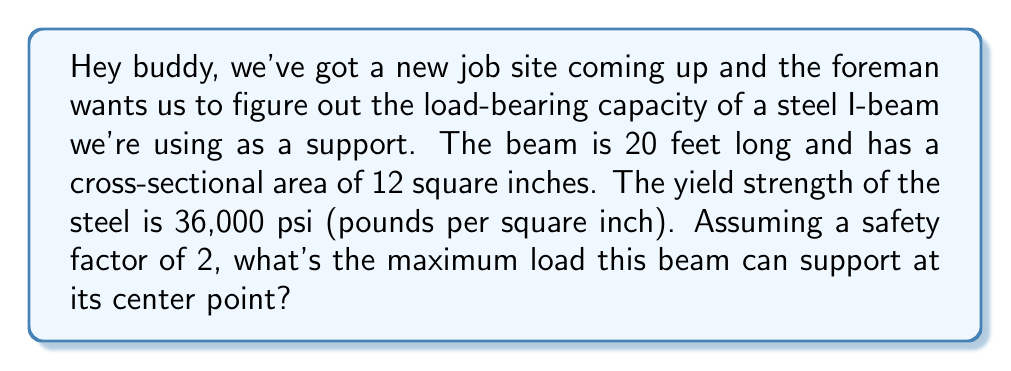Give your solution to this math problem. Alright, let's break this down step-by-step:

1) First, we need to understand the formula for maximum bending stress in a simply supported beam with a point load at the center:

   $$ \sigma_{max} = \frac{M_c}{I} $$

   Where:
   $\sigma_{max}$ is the maximum stress
   $M$ is the bending moment
   $c$ is the distance from the neutral axis to the extreme fiber
   $I$ is the moment of inertia of the cross-section

2) For a beam with a point load $P$ at the center, the maximum bending moment $M$ occurs at the center and is given by:

   $$ M = \frac{PL}{4} $$

   Where $L$ is the length of the beam.

3) Substituting this into our first equation:

   $$ \frac{PL}{4} \cdot \frac{c}{I} = \sigma_{max} $$

4) We can rearrange this to solve for $P$:

   $$ P = \frac{4\sigma_{max}I}{Lc} $$

5) Now, we don't know $I$ or $c$, but we know the cross-sectional area $A$ and the yield strength $\sigma_y$. We can use these to approximate:

   $$ P = \frac{4\sigma_y A}{L} $$

6) We're given:
   - $\sigma_y = 36,000$ psi
   - $A = 12$ sq in
   - $L = 20$ ft = 240 in
   - Safety factor = 2

7) Plugging these in:

   $$ P = \frac{4 \cdot 36,000 \cdot 12}{240} = 7,200 \text{ lbs} $$

8) Finally, we need to apply the safety factor by dividing by 2:

   $$ P_{safe} = \frac{7,200}{2} = 3,600 \text{ lbs} $$
Answer: The maximum load the beam can safely support at its center point is 3,600 lbs. 